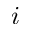<formula> <loc_0><loc_0><loc_500><loc_500>i</formula> 